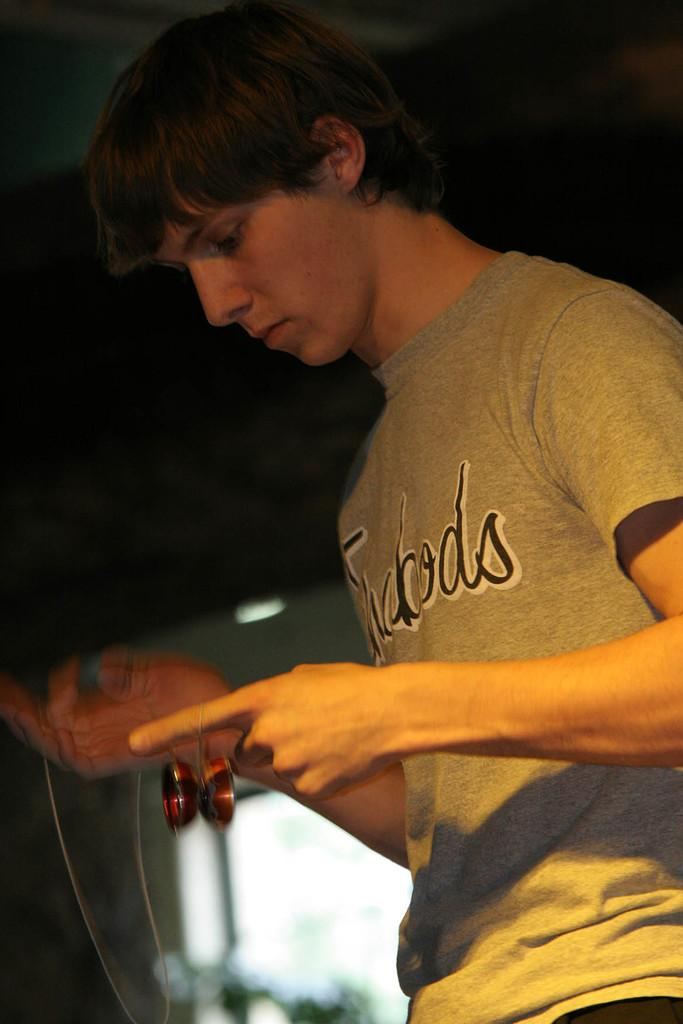What can be seen on the right side of the image? There is a person on the right side of the image. What is the person wearing? The person is wearing a T-shirt. What is the person holding in the image? The person is holding an object. Can you describe the background of the image? The background of the image is blurred. What type of geese can be seen flying in the background of the image? There are no geese present in the image; the background is blurred. What tool is the person using to fix the object in the image? The image does not show any tools, as the person is only holding an object. 